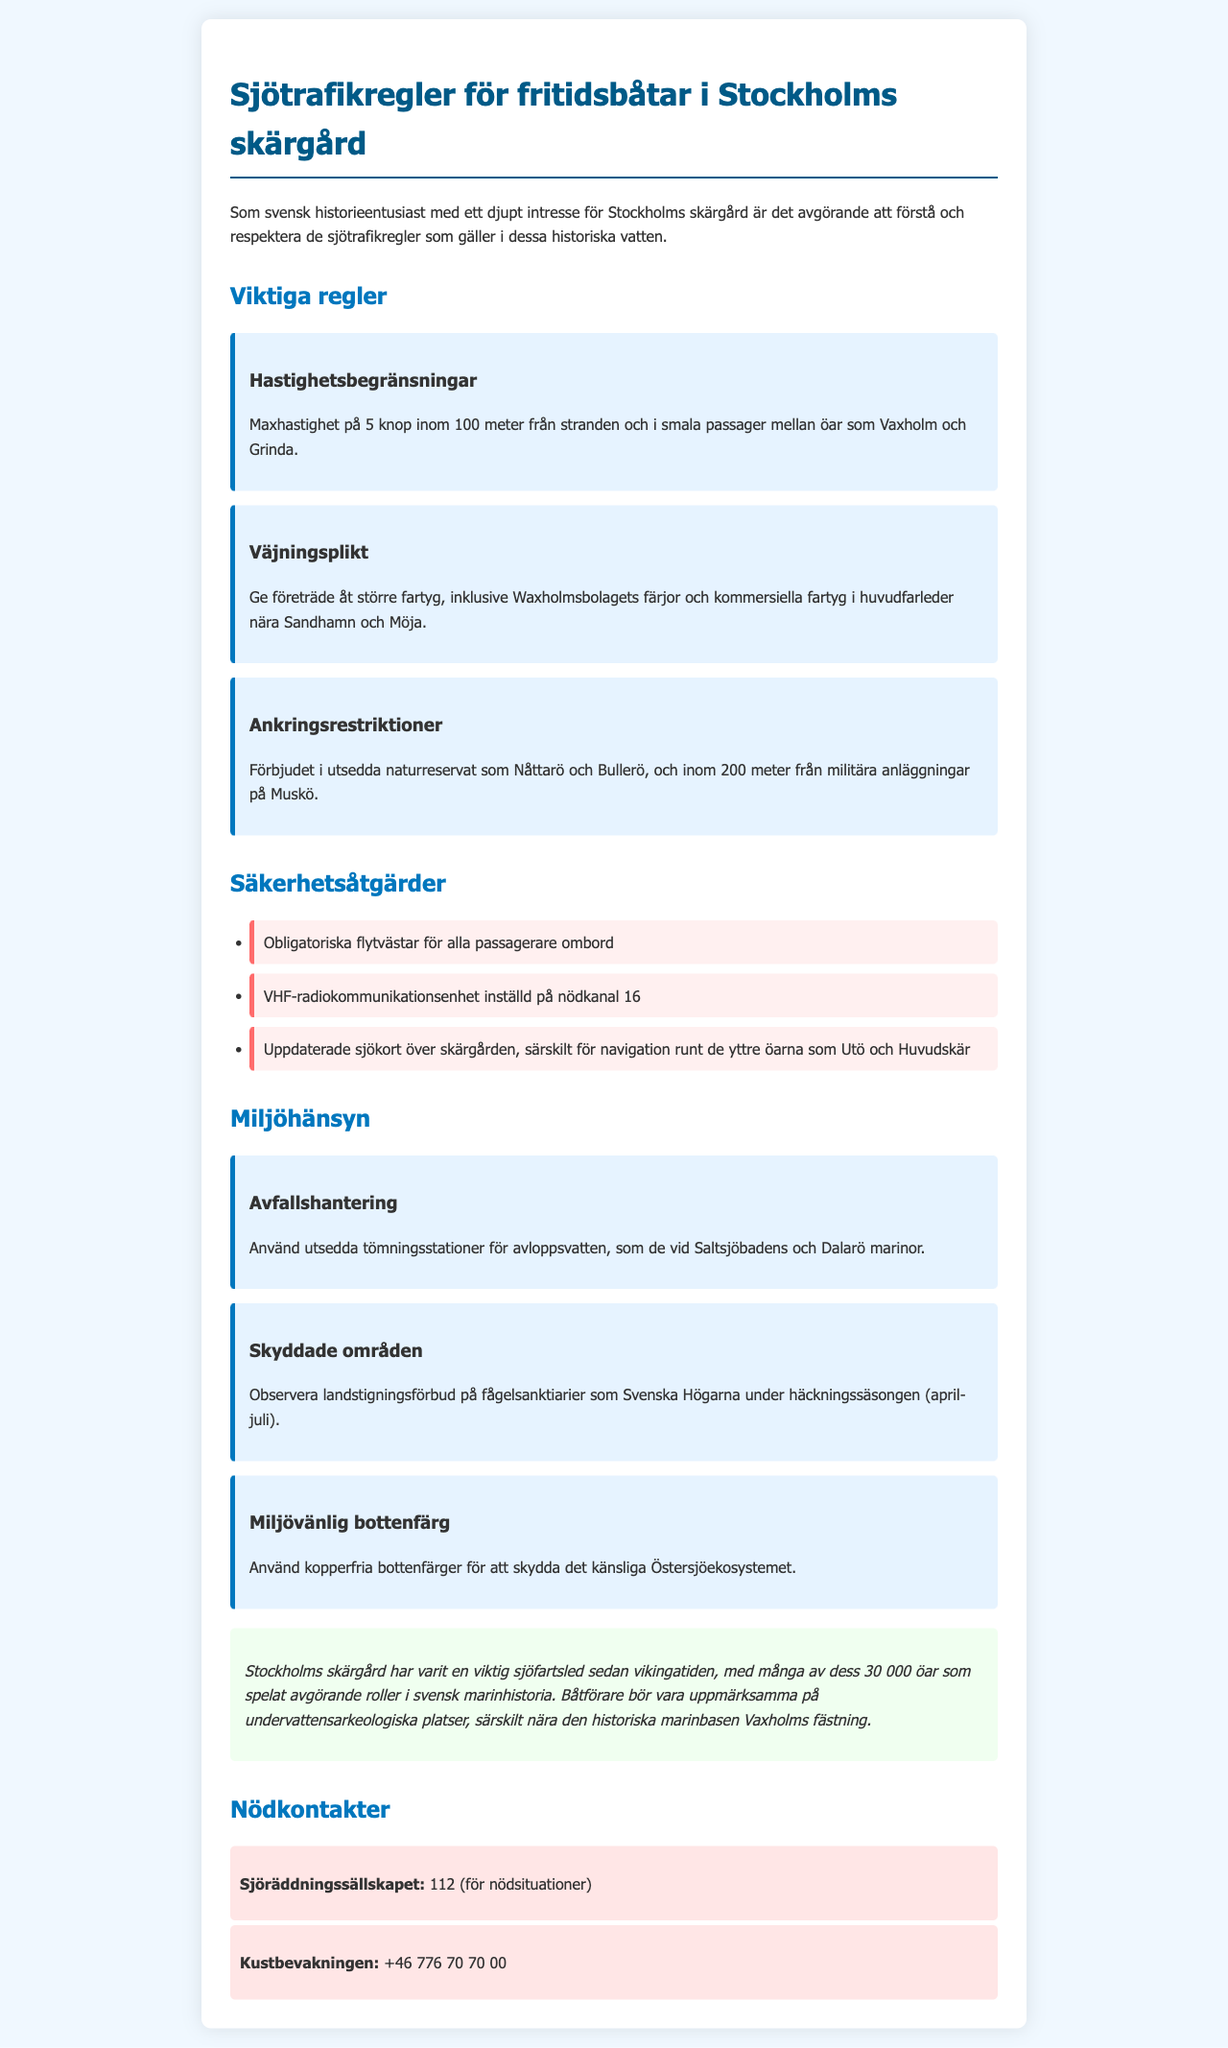What is the maximum speed allowed near the shore? The document specifies that the maximum speed is 5 knots within 100 meters from the shore.
Answer: 5 knop Which vessels must yield according to the regulations? Boaters must yield to larger vessels, including Waxholmsbolagets ferries and commercial vessels.
Answer: Större fartyg What are boaters required to wear while on board? The document states that mandatory life jackets are required for all passengers on board.
Answer: Flytvästar What type of color is recommended for eco-friendly bottom paint? The document highlights that copper-free bottom paints should be used to protect the delicate Baltic Sea ecosystem.
Answer: Kopperfria What is the emergency contact number for maritime rescue services? The document provides the emergency contact number for Sjöräddningssällskapet as 112 for emergencies.
Answer: 112 During which months is landing prohibited on bird sanctuaries? The document indicates that landing is prohibited from April to July during the nesting season.
Answer: April-juli What should boaters use to dispose of wastewater? The document advises using designated pumping stations for wastewater disposal.
Answer: Tömningstationer In which area are anchoring restrictions enforced? The document mentions that anchoring is prohibited in designated nature reserves like Nåttarö and Bullerö.
Answer: Nåttarö och Bullerö What is the historical significance of the Stockholm archipelago mentioned in the document? It states that the archipelago has been an important shipping route since the Viking Age.
Answer: Vikingatiden 